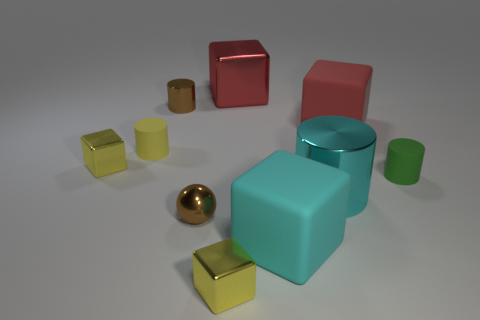Subtract all small yellow cylinders. How many cylinders are left? 3 Subtract all red balls. How many red blocks are left? 2 Subtract all cyan cylinders. How many cylinders are left? 3 Subtract 4 blocks. How many blocks are left? 1 Subtract all cylinders. How many objects are left? 6 Subtract all cyan cubes. Subtract all small yellow rubber blocks. How many objects are left? 9 Add 2 red objects. How many red objects are left? 4 Add 2 large metal things. How many large metal things exist? 4 Subtract 0 gray cylinders. How many objects are left? 10 Subtract all yellow balls. Subtract all gray cylinders. How many balls are left? 1 